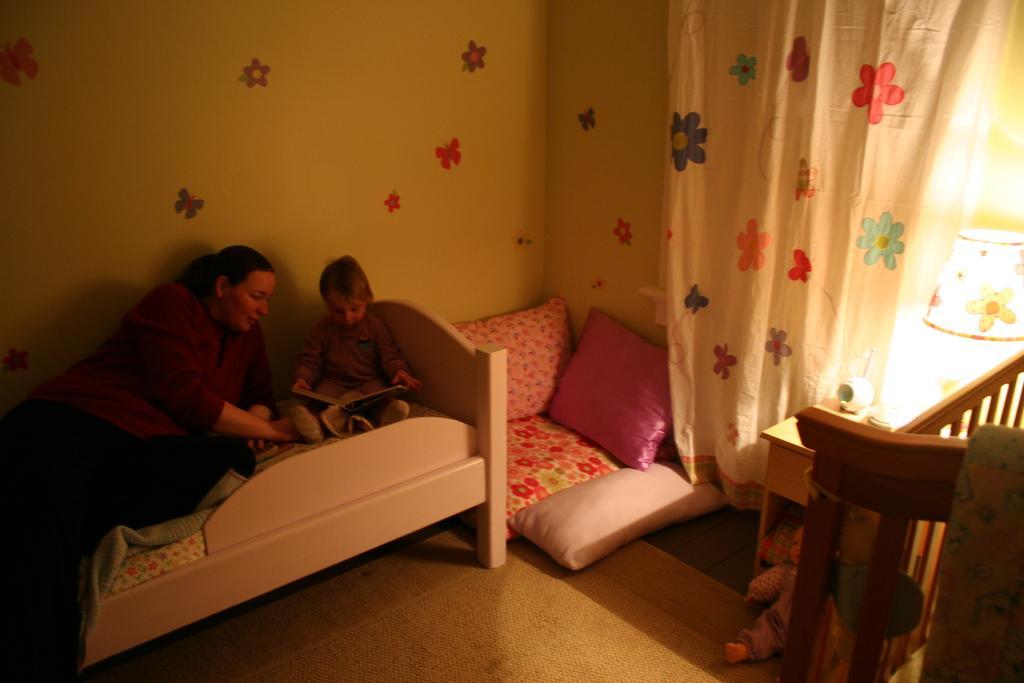How would you summarize this image in a sentence or two? In this image I can see a woman and the child on the bed. There are pillows and a floor mat. At the background we can see a color full wall and a curtain. On the table there is a lamp. 